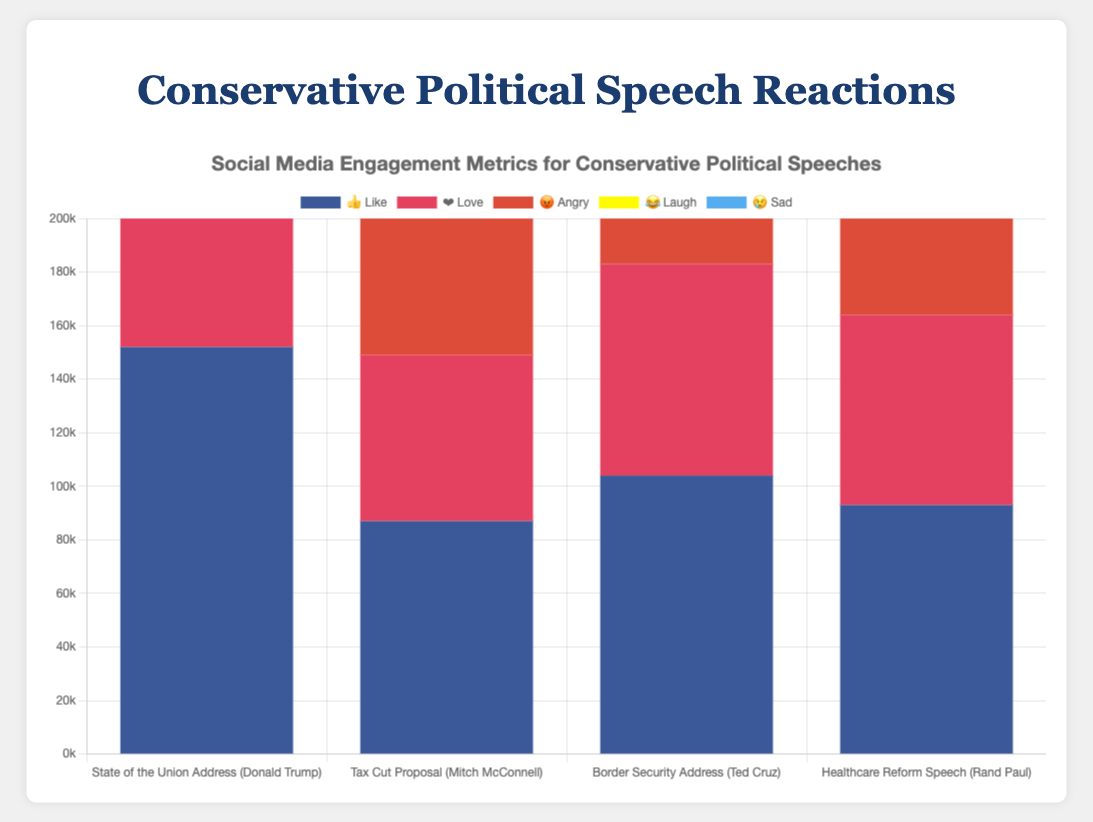What is the total number of ❤️ Love reactions for all speeches? Add the number of ❤️ Love reactions for each speech: 98,000 (Trump) + 62,000 (McConnell) + 79,000 (Cruz) + 71,000 (Paul) = 310,000
Answer: 310,000 Which speech received the highest number of 😡 Angry reactions? Compare the number of 😡 Angry reactions for each speech. Trump: 76,000, McConnell: 53,000, Cruz: 68,000, Paul: 59,000. Trump has the highest with 76,000
Answer: State of the Union Address How many 👍 Like reactions did the Tax Cut Proposal speech receive? Look at the like reactions for McConnell's speech on Twitter, which are 87,000
Answer: 87,000 Which speech had more 😂 Laugh reactions, the State of the Union Address or the Healthcare Reform Speech? Compare the 😂 Laugh reactions. State of the Union Address: 45,000, Healthcare Reform Speech: 42,000. The former is greater
Answer: State of the Union Address What is the difference in the total number of 😢 Sad reactions between the Healthcare Reform Speech and the Border Security Address? Subtract the 😢 Sad reactions for the Border Security Address (25,000) from those for the Healthcare Reform Speech (28,000): 28,000 - 25,000 = 3,000
Answer: 3,000 What's the average number of 👍 Like reactions per speech? Sum the 👍 Like reactions: 152,000 (Trump) + 87,000 (McConnell) + 104,000 (Cruz) + 93,000 (Paul) = 436,000. Average = 436,000 / 4 = 109,000
Answer: 109,000 How many total reactions did the Border Security Address receive? Sum all emoji reactions for the Border Security Address: 104,000 (👍) + 79,000 (❤️) + 68,000 (😡) + 37,000 (😂) + 25,000 (😢) = 313,000
Answer: 313,000 Which speech had the least number of 😢 Sad reactions? Compare the 😢 Sad reactions for each speech. Trump: 23,000, McConnell: 19,000, Cruz: 25,000, Paul: 28,000. The least is McConnell with 19,000
Answer: Tax Cut Proposal What percentage of total reactions for the State of the Union Address are 😡 Angry reactions? First, find total reactions for the State of the Union Address: 152,000 (👍) + 98,000 (❤️) + 76,000 (😡) + 45,000 (😂) + 23,000 (😢) = 394,000. Then, calculate the percentage: (76,000 / 394,000) * 100 ≈ 19.29%
Answer: 19.29% Which platform received the highest number of ❤️ Love reactions? Compare the total ❤️ Love reactions across platforms: Facebook (Trump): 98,000, Twitter (McConnell): 62,000, Instagram (Cruz): 79,000, YouTube (Paul): 71,000. Facebook has the highest with 98,000
Answer: Facebook 